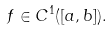<formula> <loc_0><loc_0><loc_500><loc_500>f \in C ^ { 1 } ( [ a , b ] ) .</formula> 